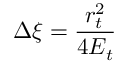<formula> <loc_0><loc_0><loc_500><loc_500>\Delta \xi = \frac { r _ { t } ^ { 2 } } { 4 E _ { t } }</formula> 